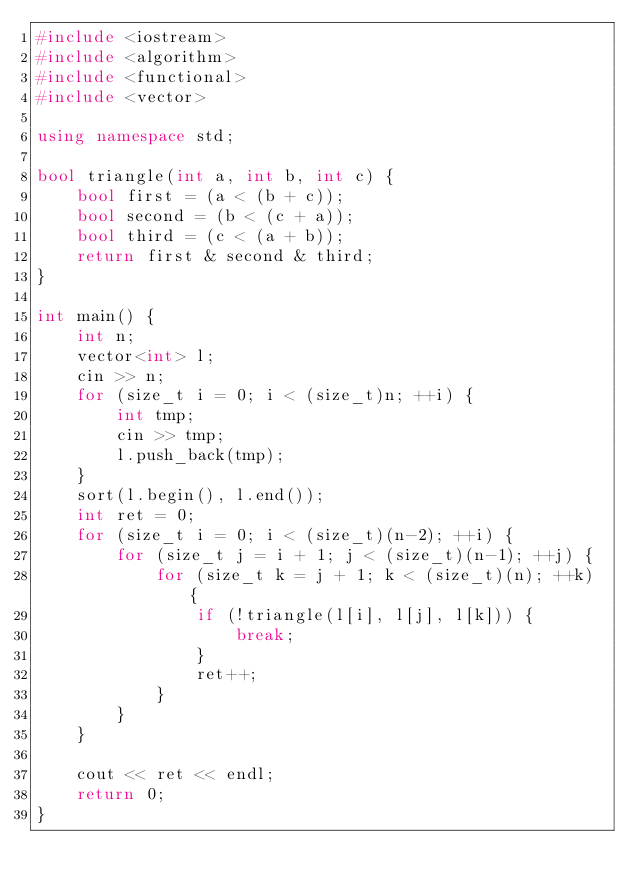Convert code to text. <code><loc_0><loc_0><loc_500><loc_500><_C++_>#include <iostream>
#include <algorithm>
#include <functional>
#include <vector>

using namespace std;

bool triangle(int a, int b, int c) {
    bool first = (a < (b + c));
    bool second = (b < (c + a));
    bool third = (c < (a + b));
    return first & second & third;
}

int main() {
    int n;
    vector<int> l;
    cin >> n;
    for (size_t i = 0; i < (size_t)n; ++i) {
        int tmp;
        cin >> tmp;
        l.push_back(tmp);
    }
    sort(l.begin(), l.end());
    int ret = 0;
    for (size_t i = 0; i < (size_t)(n-2); ++i) {
        for (size_t j = i + 1; j < (size_t)(n-1); ++j) {
            for (size_t k = j + 1; k < (size_t)(n); ++k) {
                if (!triangle(l[i], l[j], l[k])) {
                    break;
                }
                ret++;
            }
        }
    }

    cout << ret << endl;
    return 0;
}</code> 